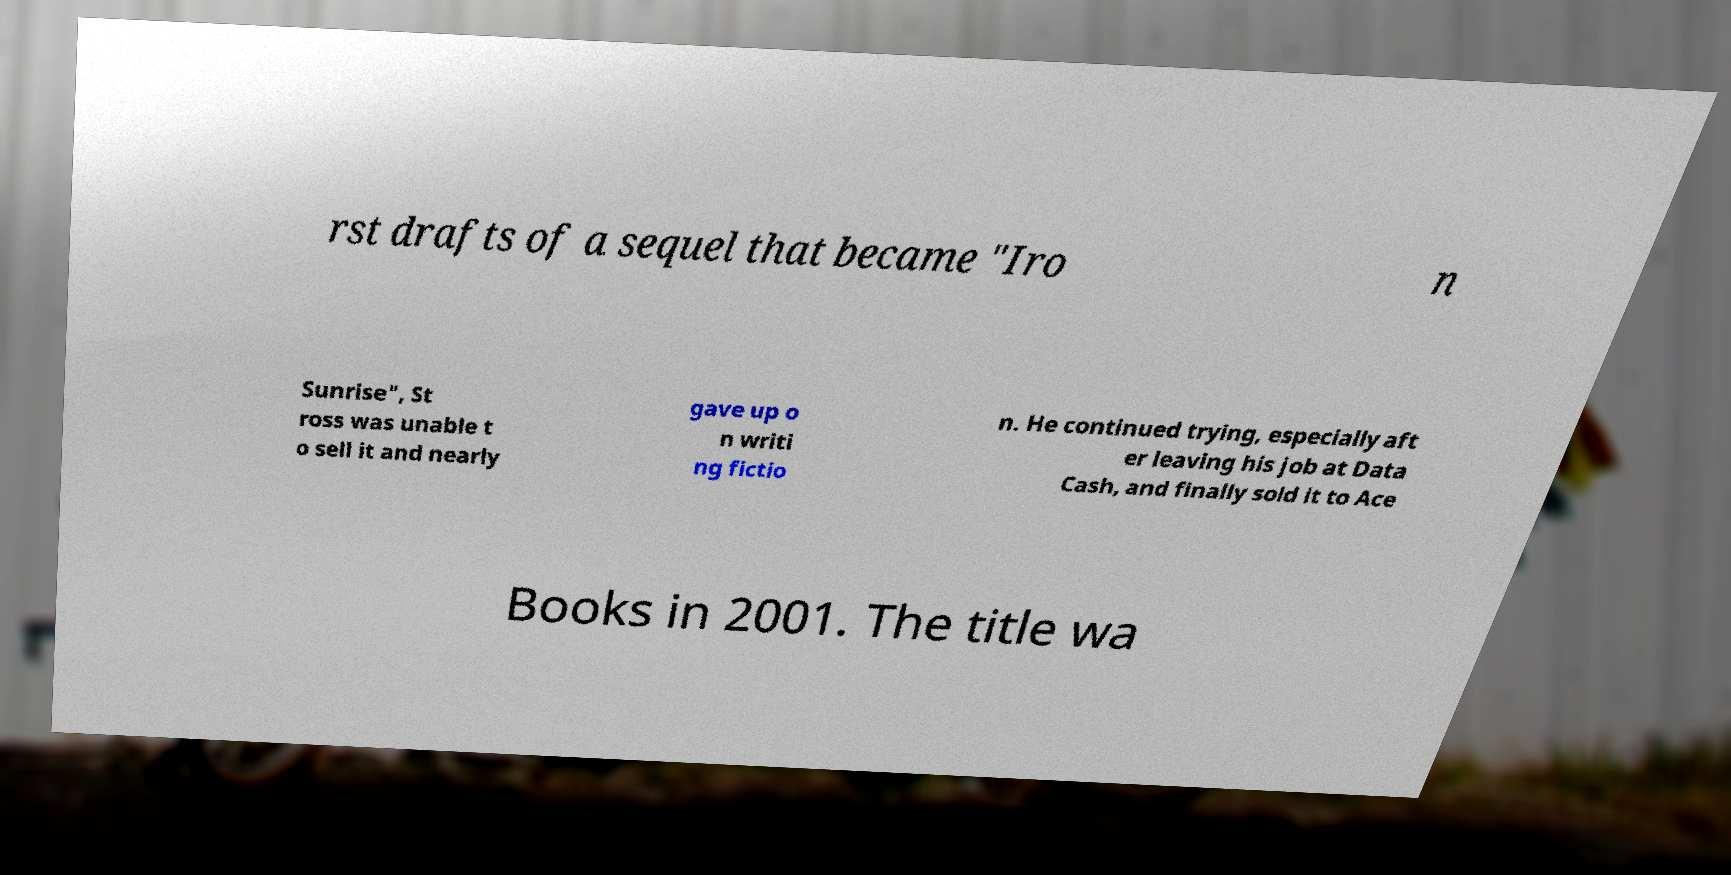Could you extract and type out the text from this image? rst drafts of a sequel that became "Iro n Sunrise", St ross was unable t o sell it and nearly gave up o n writi ng fictio n. He continued trying, especially aft er leaving his job at Data Cash, and finally sold it to Ace Books in 2001. The title wa 